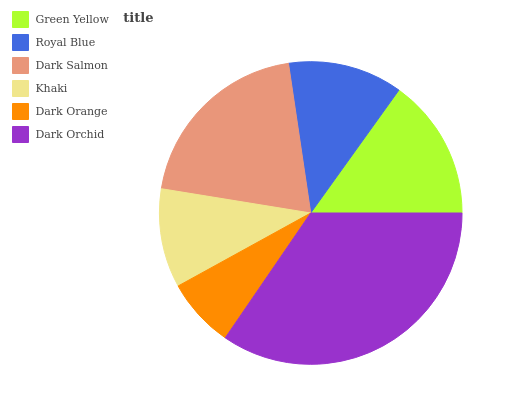Is Dark Orange the minimum?
Answer yes or no. Yes. Is Dark Orchid the maximum?
Answer yes or no. Yes. Is Royal Blue the minimum?
Answer yes or no. No. Is Royal Blue the maximum?
Answer yes or no. No. Is Green Yellow greater than Royal Blue?
Answer yes or no. Yes. Is Royal Blue less than Green Yellow?
Answer yes or no. Yes. Is Royal Blue greater than Green Yellow?
Answer yes or no. No. Is Green Yellow less than Royal Blue?
Answer yes or no. No. Is Green Yellow the high median?
Answer yes or no. Yes. Is Royal Blue the low median?
Answer yes or no. Yes. Is Royal Blue the high median?
Answer yes or no. No. Is Dark Orchid the low median?
Answer yes or no. No. 